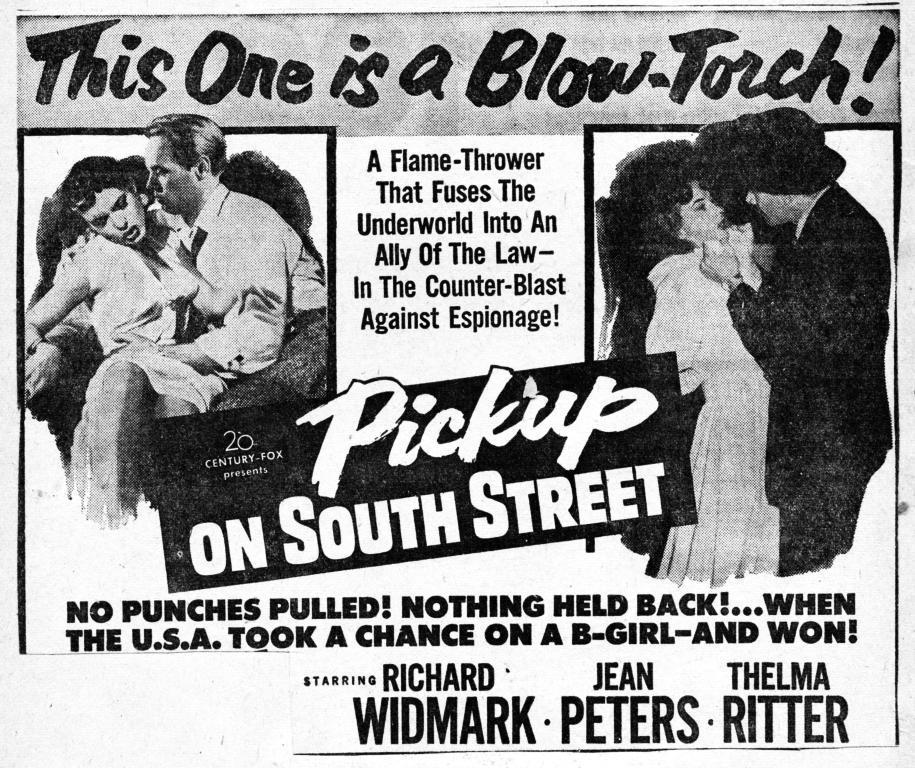How would you summarize this image in a sentence or two? In this image there is a poster with pictures of a couple and some text written on it. 